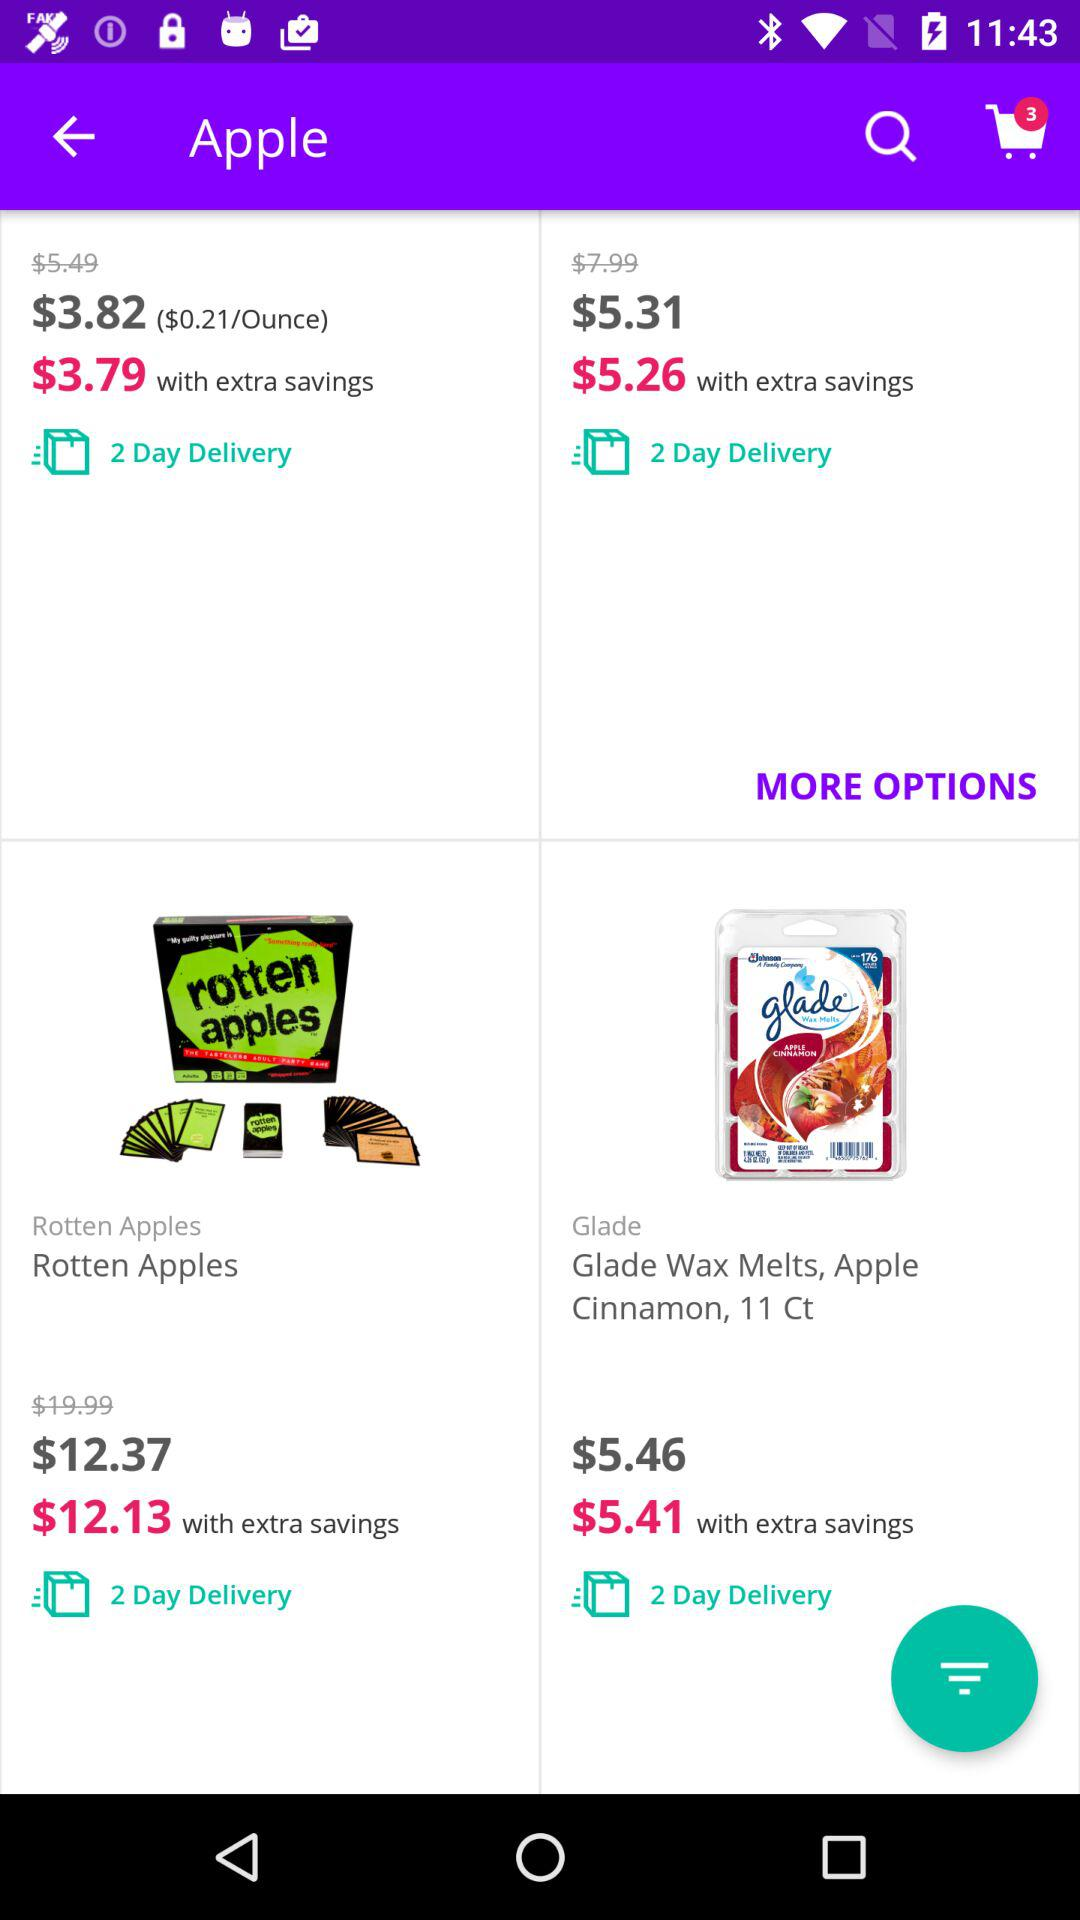What is the price for the Rotten Apples? The price for the Rotten Apples is $12.37. 